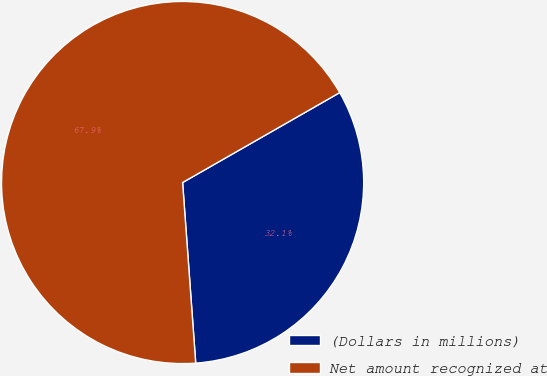Convert chart. <chart><loc_0><loc_0><loc_500><loc_500><pie_chart><fcel>(Dollars in millions)<fcel>Net amount recognized at<nl><fcel>32.12%<fcel>67.88%<nl></chart> 